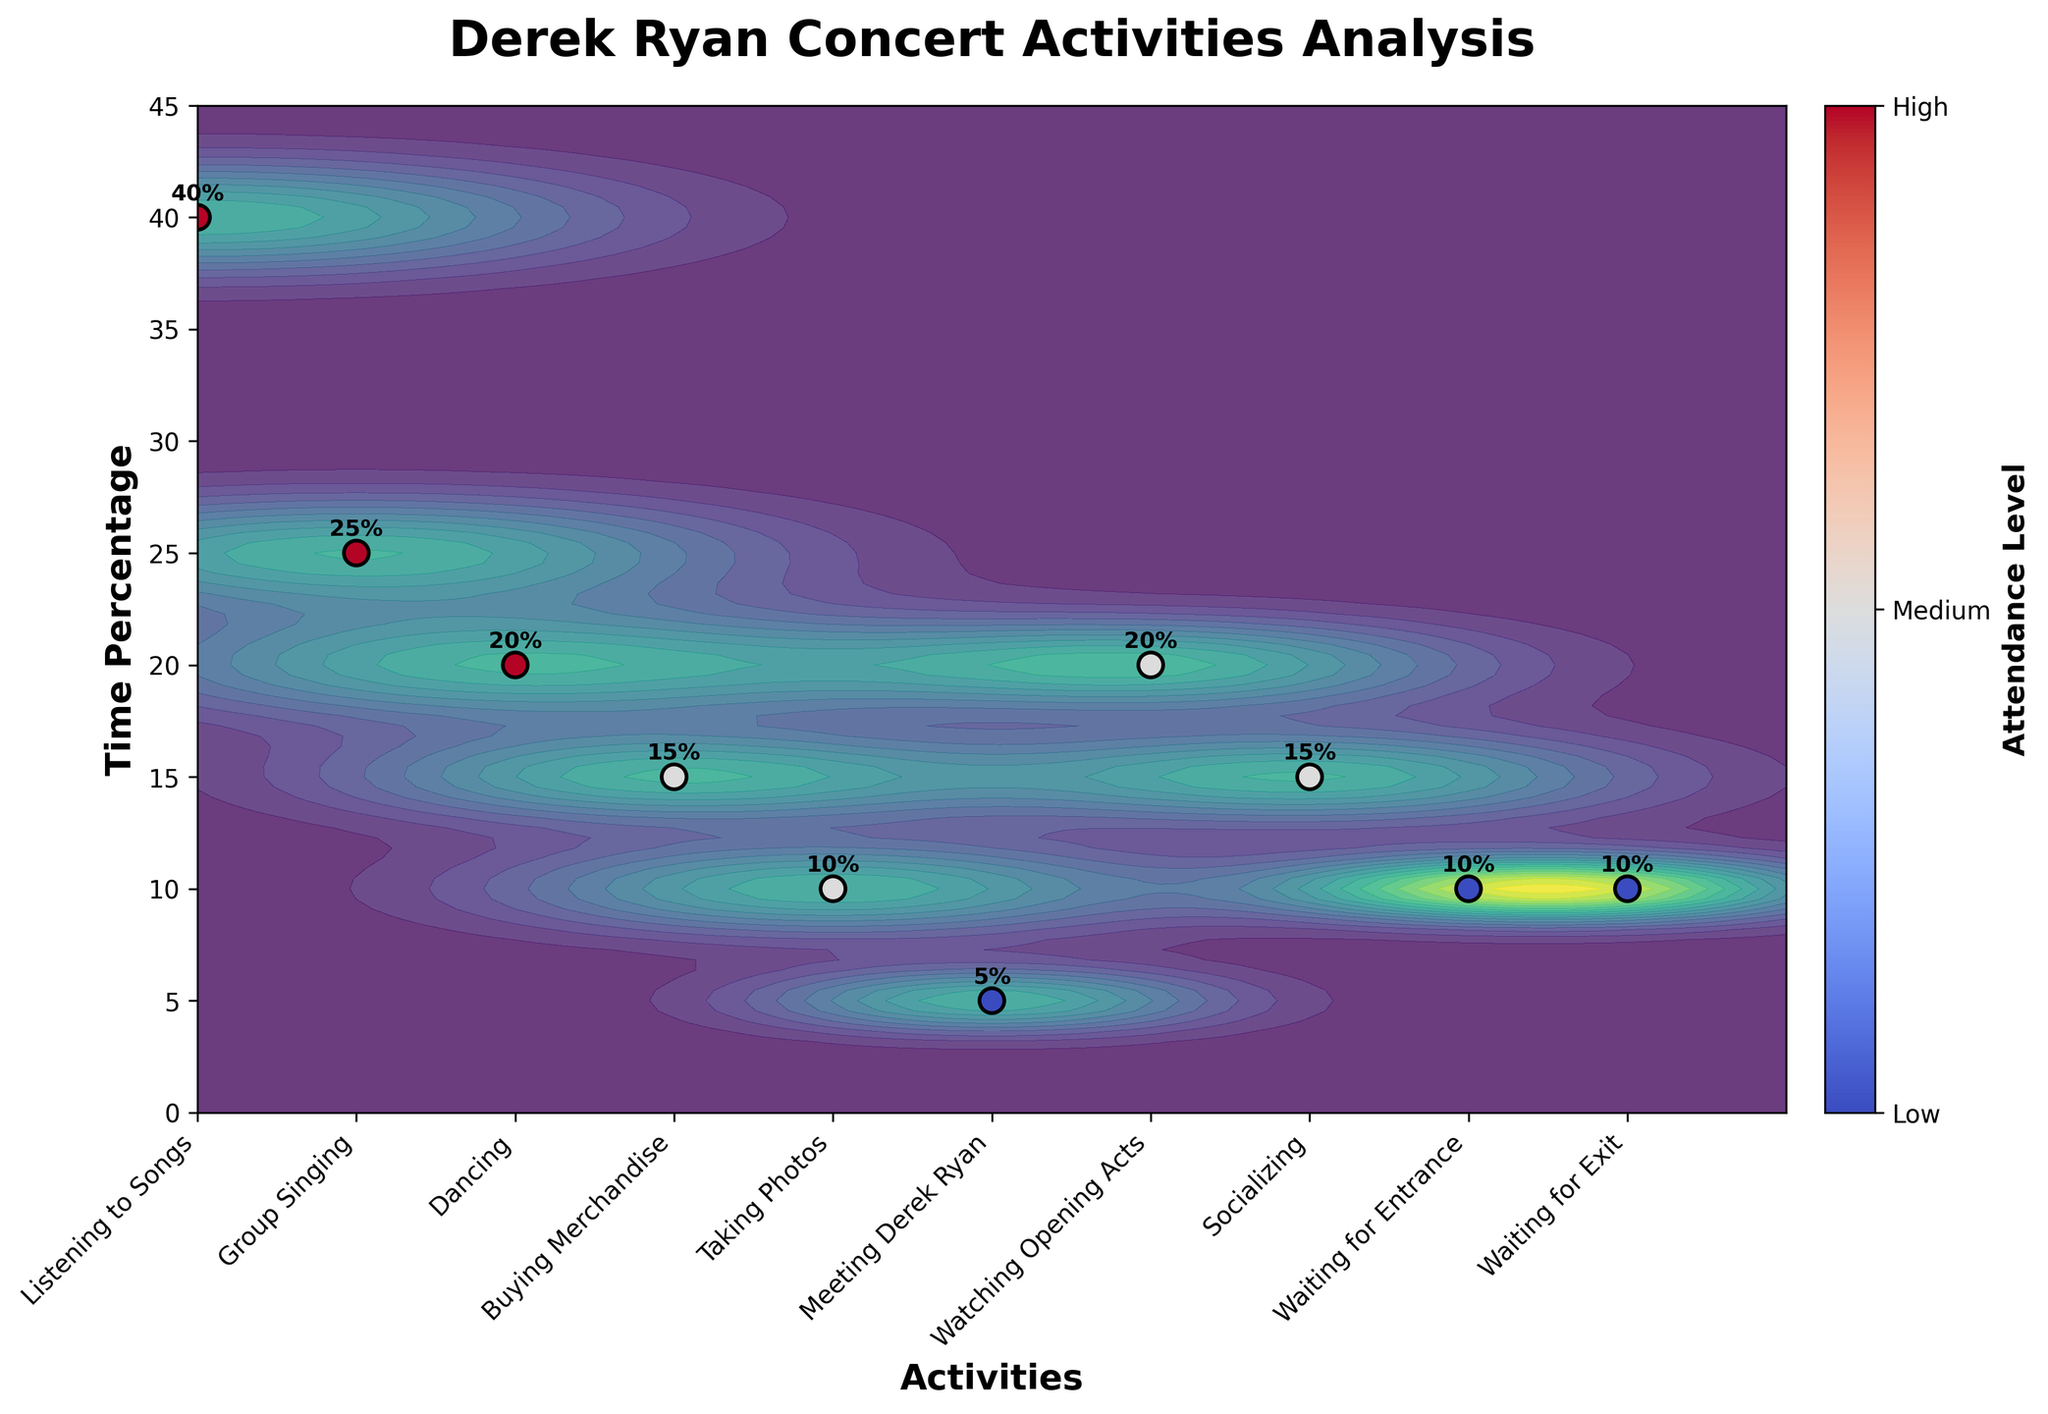What is the title of the plot? The title is clearly displayed at the top of the plot in a larger and bold font.
Answer: Derek Ryan Concert Activities Analysis What are the x-axis and y-axis labels? The x-axis label is displayed at the bottom in bold, and the y-axis label is displayed on the left side in bold.
Answer: x-axis: Activities, y-axis: Time Percentage How many activities are represented in the plot? Count the number of unique labels on the x-axis; each represents a different activity. There are 10 activities listed.
Answer: 10 Which activity has the highest time percentage? Looking at the y-axis values corresponding to each labeled activity on the x-axis, the highest point is for "Listening to Songs."
Answer: Listening to Songs Which activities have the least time percentage? Identify the activities with the lowest positions on the y-axis. "Meeting Derek Ryan," "Waiting for Entrance," and "Waiting for Exit" all have the lowest time percentages.
Answer: Meeting Derek Ryan, Waiting for Entrance, Waiting for Exit How is the attendance level indicated in the plot? The attendance is indicated by the color and size of the data points, with a colorbar explaining the attendance levels from Low to High.
Answer: Color and size of data points What are the time percentages for Group Singing and Dancing? Locate "Group Singing" and "Dancing" on the x-axis, and read off their corresponding y-axis values. Group Singing is 25% and Dancing is 20%.
Answer: Group Singing: 25%, Dancing: 20% Which activities have medium attendance levels? Look at the color of the data points corresponding to medium attendance levels as indicated by the colorbar, then identify the activities.
Answer: Buying Merchandise, Taking Photos, Watching Opening Acts, Socializing Is the time percentage for Socializing higher than for Buying Merchandise? Compare the y-axis value for "Socializing" and "Buying Merchandise." Socializing is 15%, and Buying Merchandise is also 15%. They are the same.
Answer: No, they are the same Which activity is closer in time percentage to Taking Photos: Dancing or Group Singing? Compare the time percentages for "Dancing" (20%) and "Group Singing" (25%) to "Taking Photos" (10%). "Dancing" is closer at 20%.
Answer: Dancing 